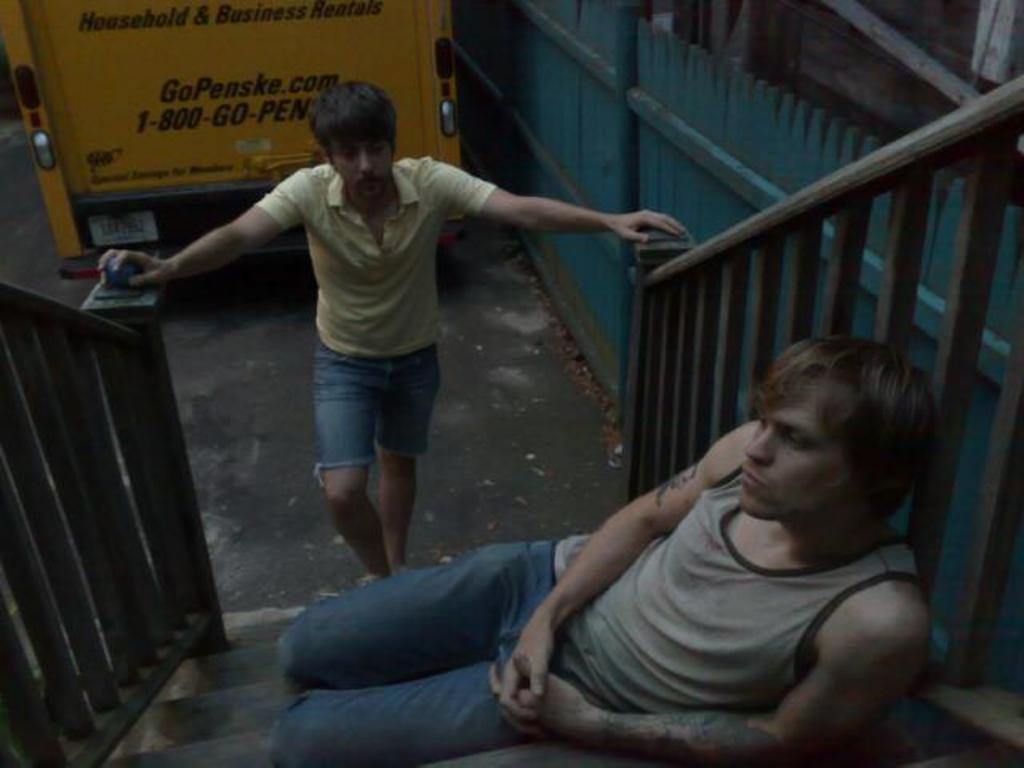In one or two sentences, can you explain what this image depicts? In front of the image there is a person sitting on the stairs. Behind him there is another person standing. There is a railing. In the background of the image there is a vehicle on the road. On the right side of the image there is a metal fence. 